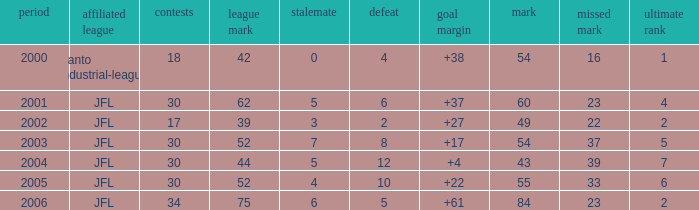I want the total number of matches for draw less than 7 and lost point of 16 with lose more than 4 0.0. 